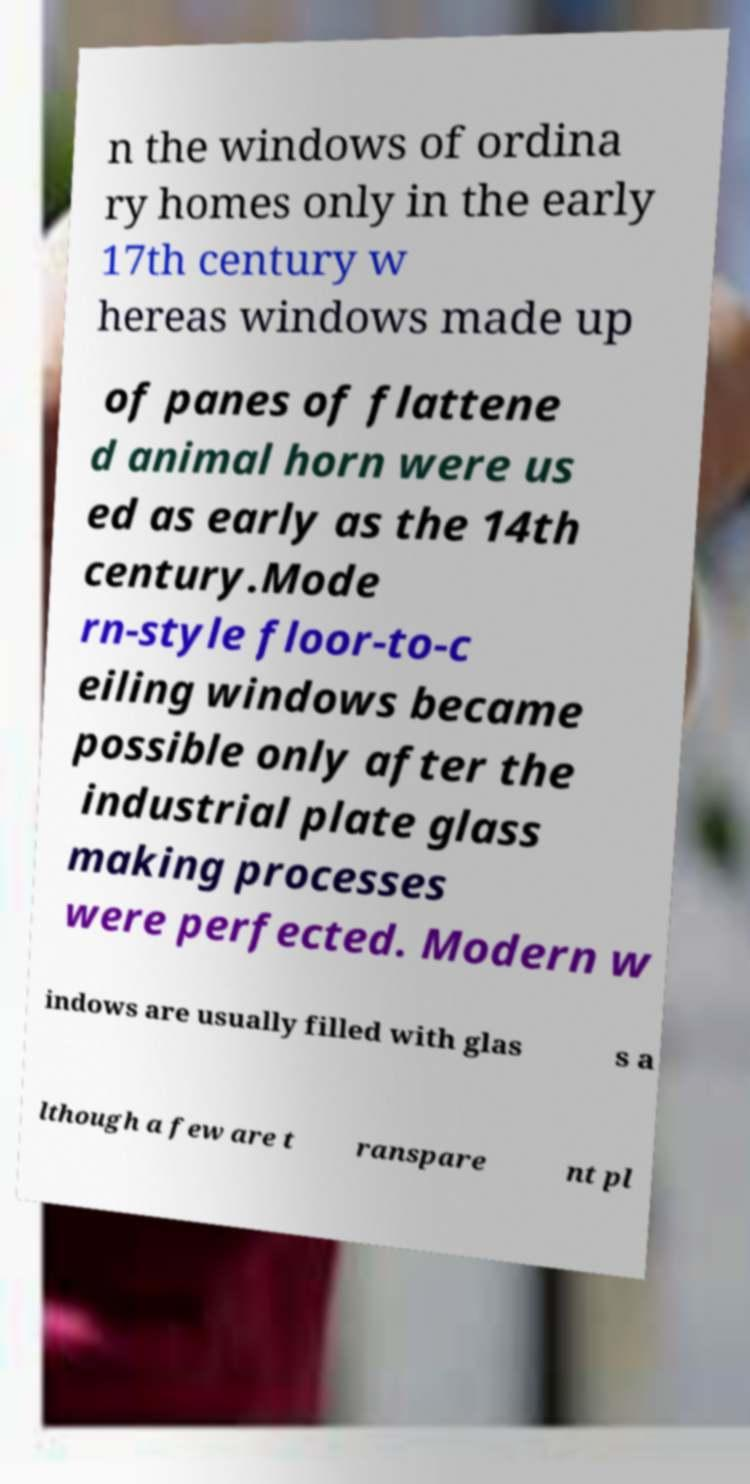Can you accurately transcribe the text from the provided image for me? n the windows of ordina ry homes only in the early 17th century w hereas windows made up of panes of flattene d animal horn were us ed as early as the 14th century.Mode rn-style floor-to-c eiling windows became possible only after the industrial plate glass making processes were perfected. Modern w indows are usually filled with glas s a lthough a few are t ranspare nt pl 